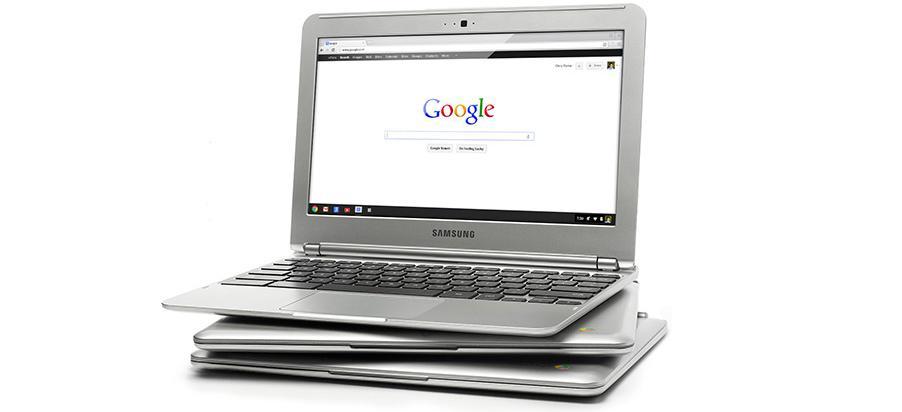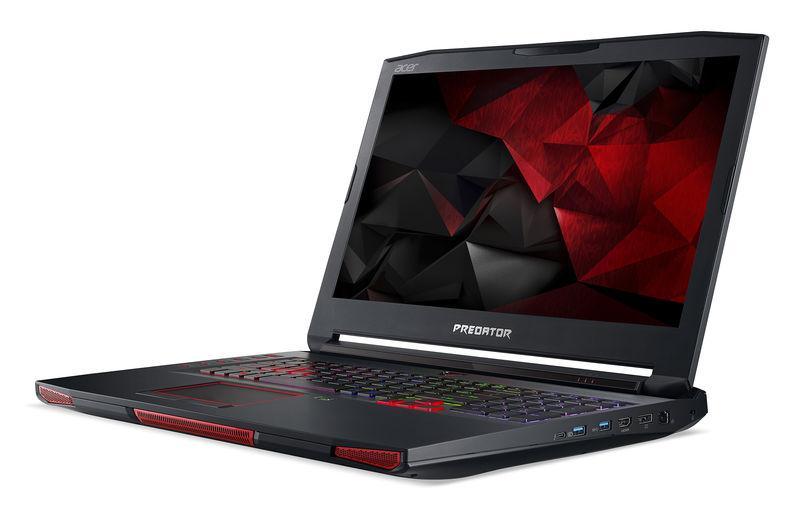The first image is the image on the left, the second image is the image on the right. Analyze the images presented: Is the assertion "There is a black laptop that is opened." valid? Answer yes or no. Yes. The first image is the image on the left, the second image is the image on the right. Considering the images on both sides, is "there is a pile of laptops in the image on the left, and all visible screens are dark" valid? Answer yes or no. No. 